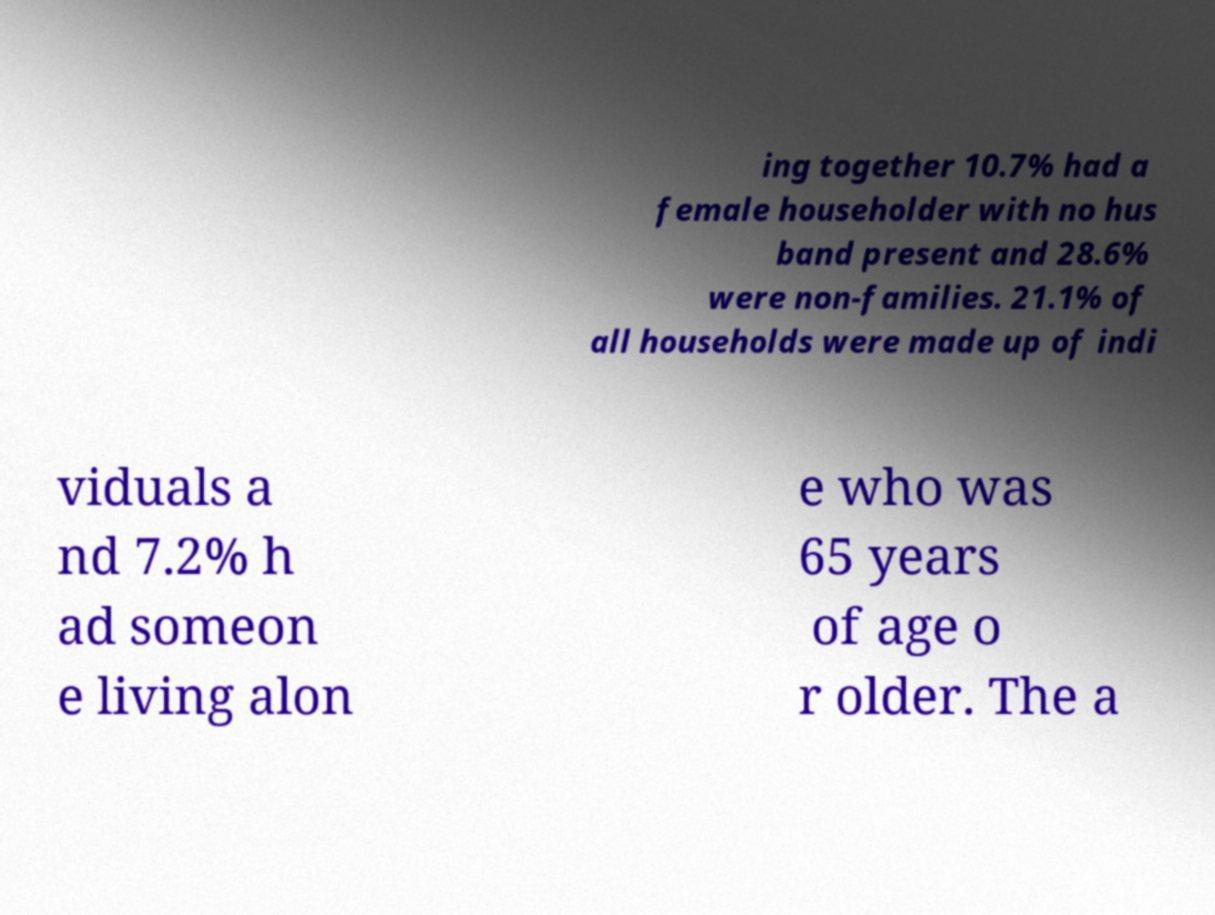Please identify and transcribe the text found in this image. ing together 10.7% had a female householder with no hus band present and 28.6% were non-families. 21.1% of all households were made up of indi viduals a nd 7.2% h ad someon e living alon e who was 65 years of age o r older. The a 